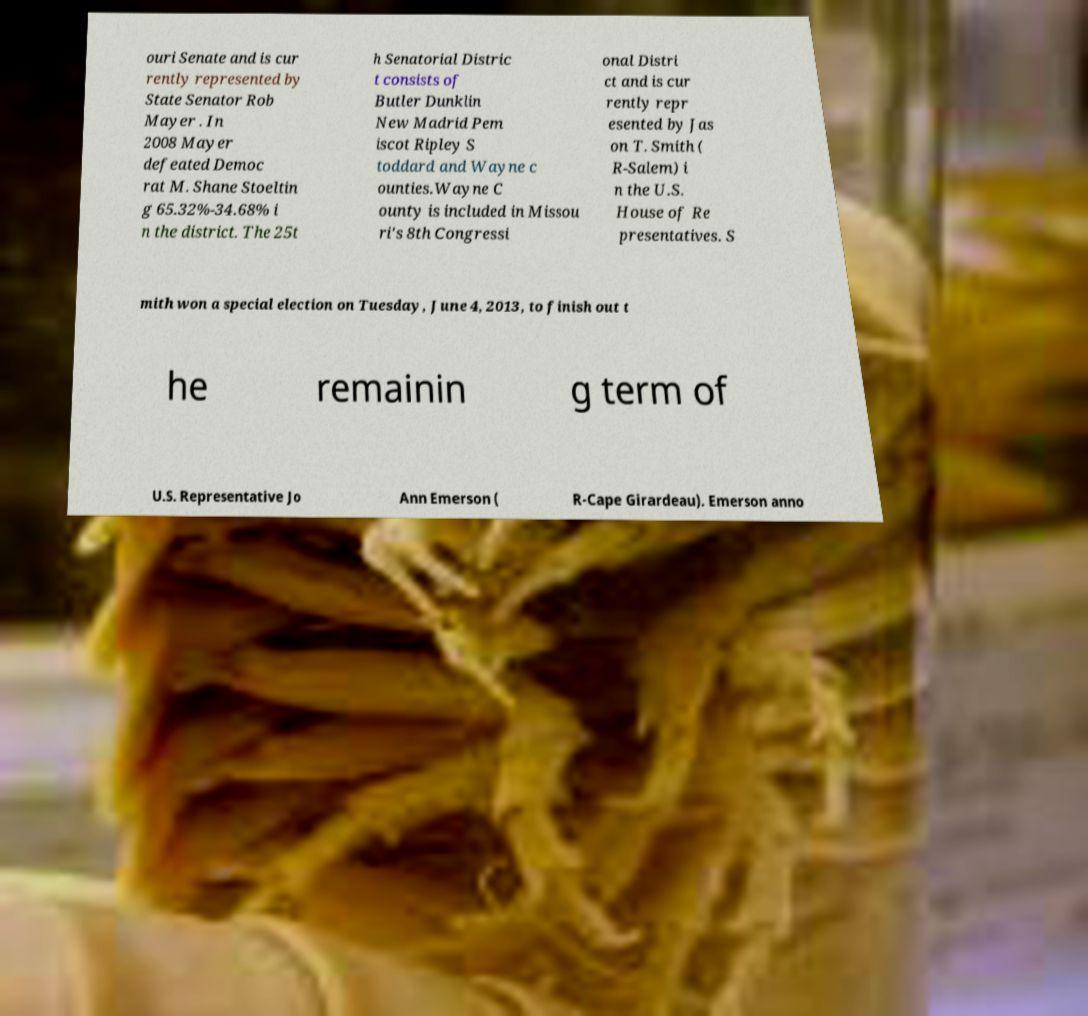There's text embedded in this image that I need extracted. Can you transcribe it verbatim? ouri Senate and is cur rently represented by State Senator Rob Mayer . In 2008 Mayer defeated Democ rat M. Shane Stoeltin g 65.32%-34.68% i n the district. The 25t h Senatorial Distric t consists of Butler Dunklin New Madrid Pem iscot Ripley S toddard and Wayne c ounties.Wayne C ounty is included in Missou ri's 8th Congressi onal Distri ct and is cur rently repr esented by Jas on T. Smith ( R-Salem) i n the U.S. House of Re presentatives. S mith won a special election on Tuesday, June 4, 2013, to finish out t he remainin g term of U.S. Representative Jo Ann Emerson ( R-Cape Girardeau). Emerson anno 